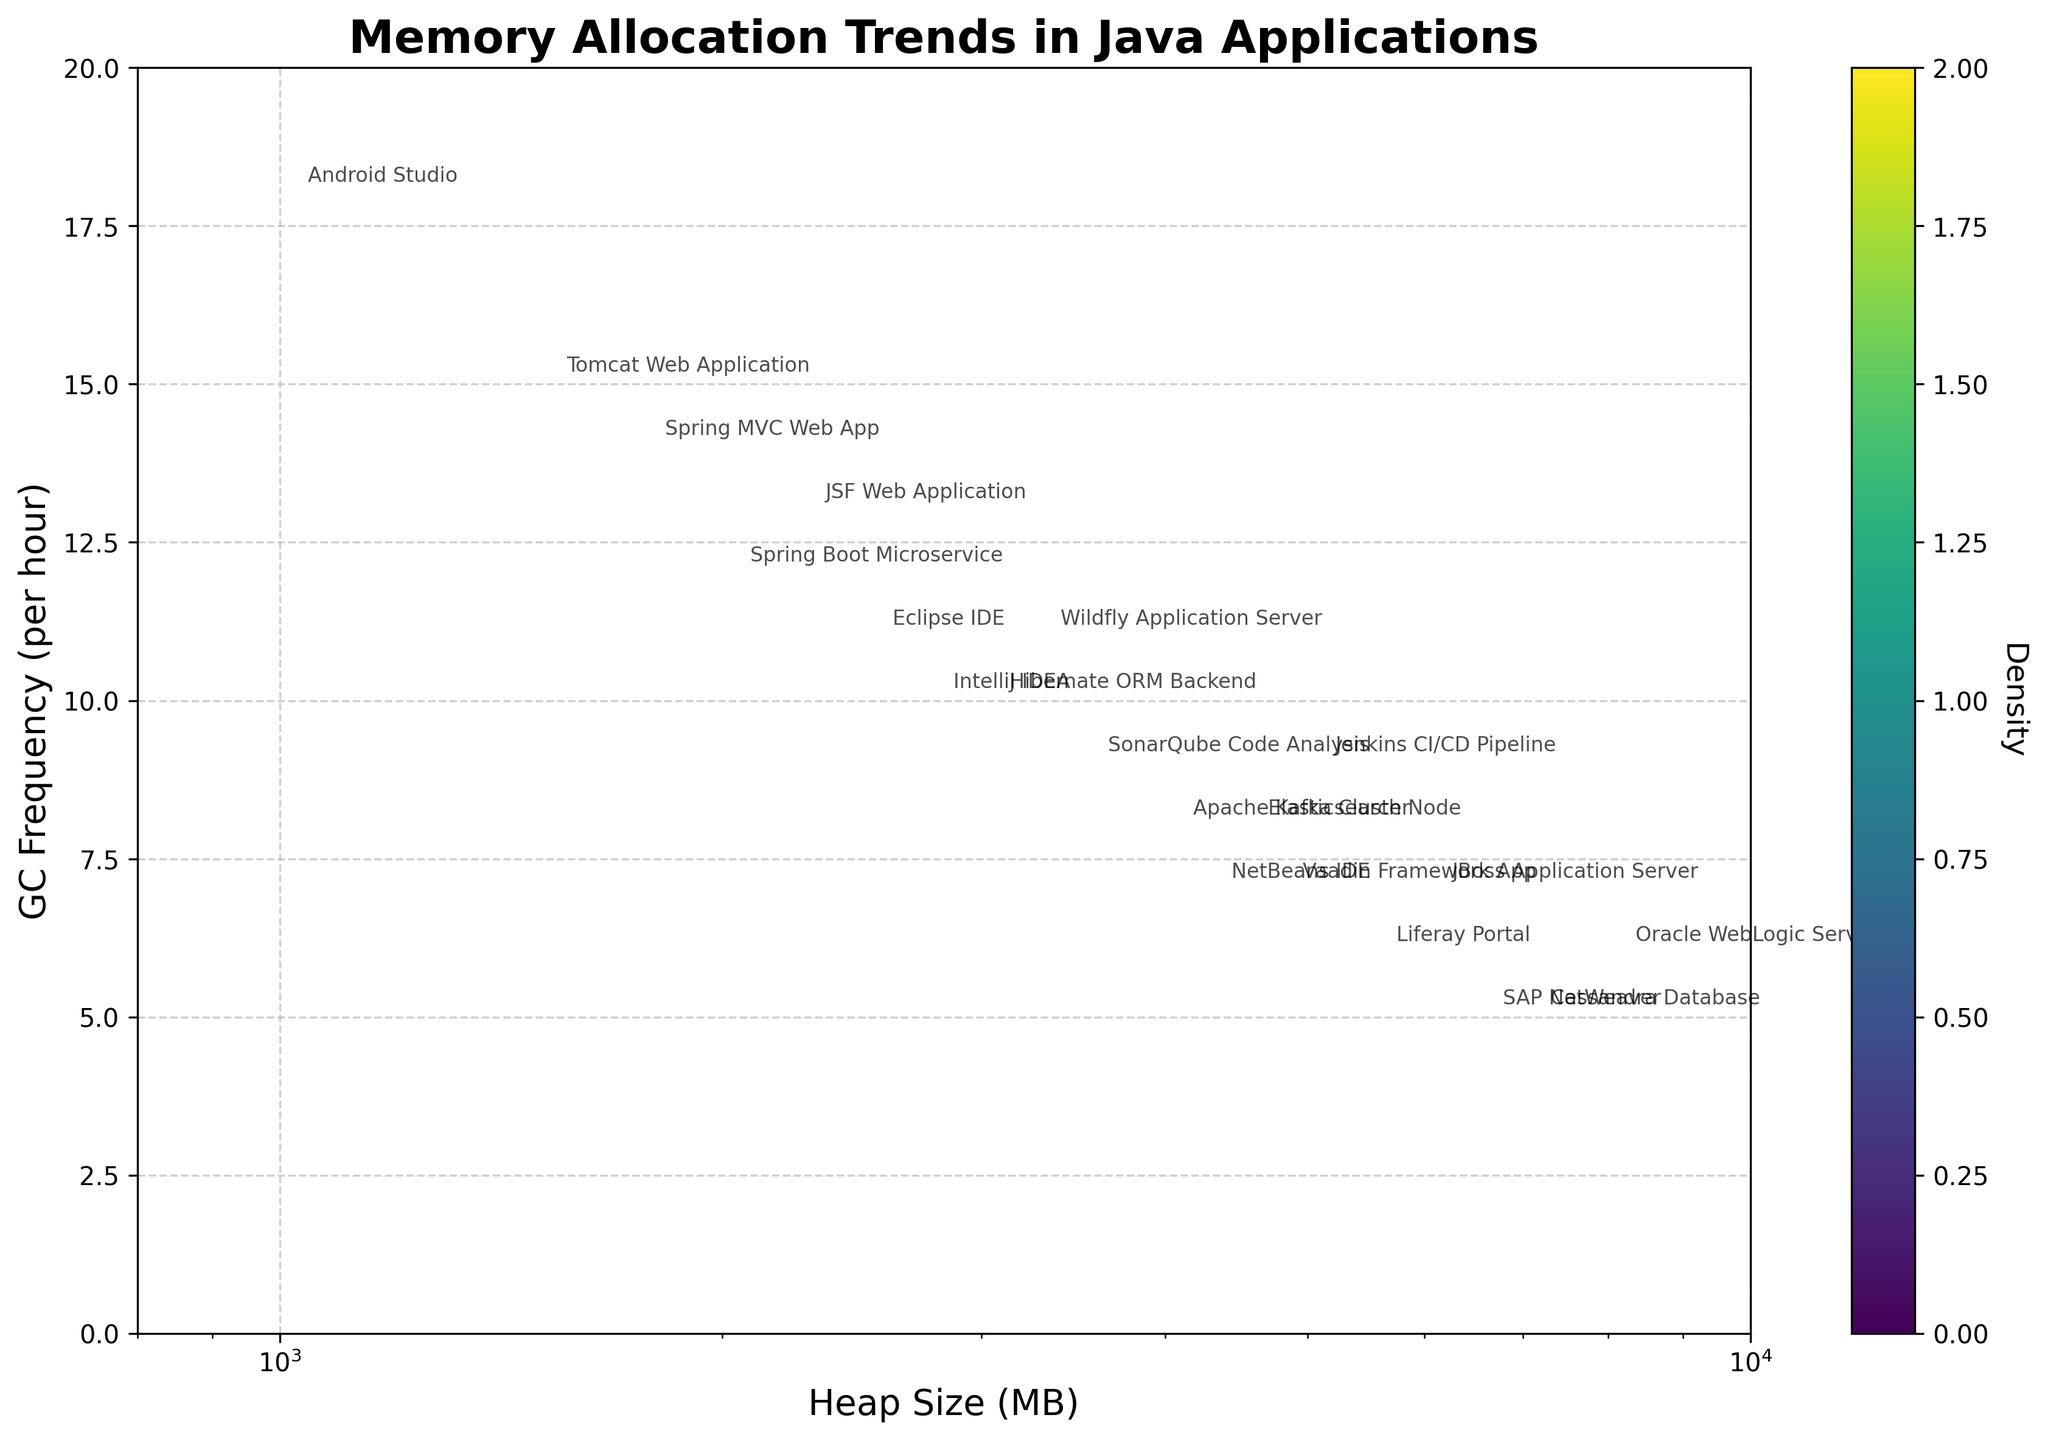What's the title of the plot? The title is typically located at the top of a plot and specifies what the plot represents. In this case, it is "Memory Allocation Trends in Java Applications."
Answer: Memory Allocation Trends in Java Applications What are the axes labels? The axes labels are found along the horizontal (x) and vertical (y) axes to indicate what each axis represents. For this plot, the x-axis is labeled "Heap Size (MB)," and the y-axis is labeled "GC Frequency (per hour)."
Answer: Heap Size (MB) and GC Frequency (per hour) What is the average heap size of the applications shown in the plot? To find the average heap size, sum the heap sizes of all the applications and divide by the number of applications. Sum = 2048 + 4096 + 8192 + 1536 + 3072 + 6144 + 2560 + 5120 + 4608 + 7168 + 3584 + 1024 + 2816 + 4352 + 5632 + 3328 + 6656 + 1792 + 4864 + 2304 = 83536. Number of applications = 20. Average heap size = 83536 / 20 = 4176.8 MB.
Answer: 4176.8 MB Which application has the highest garbage collection frequency? By looking at the y-axis values and the labeled points in the plot, we can see that "Android Studio" has the highest garbage collection frequency of 18 per hour.
Answer: Android Studio Which applications have a garbage collection frequency of 10 per hour? The points corresponding to a garbage collection frequency of 10 per hour can be identified by looking at the y-axis value of 10. These applications are "Hibernate ORM Backend" and "IntelliJ IDEA."
Answer: Hibernate ORM Backend and IntelliJ IDEA Which application uses the largest heap size? Examine the x-axis and the labeled points for the highest heap size value. "Oracle WebLogic Server" uses the largest heap size of 8192 MB.
Answer: Oracle WebLogic Server What range of heap sizes shows the densest concentration of applications? On a hexbin plot, the densest concentration of data points is indicated by the darkest hexagons. The densest concentration appears to be in the range of approximately 2048 to 5120 MB.
Answer: 2048 to 5120 MB How does the heap size relate to garbage collection frequency? By observing the trend in the plot, it generally shows that as heap size increases, the garbage collection frequency tends to decrease.
Answer: As heap size increases, GC frequency tends to decrease What is the density value around the most frequent garbage collection rates? The most frequent garbage collection rates lie around 10 to 12 per hour. The density value in these ranges is indicated by the color intensity, commonly in the mid to darker range on the color scale (viridis).
Answer: Mid to high density What is the garbage collection frequency of an application with a heap size of approximately 1792 MB? Finding the point labeled "Spring MVC Web App" near the x-value of 1792 MB on the plot, it is annotated with a garbage collection frequency of 14 per hour.
Answer: 14 per hour 